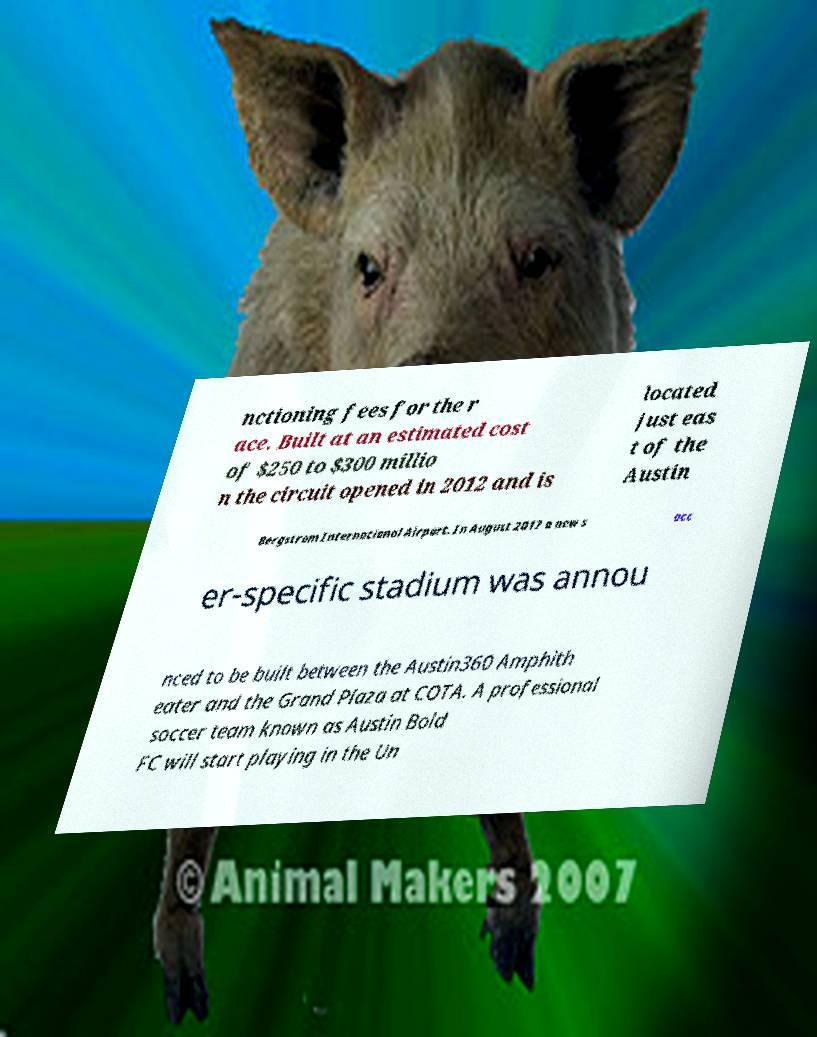Please identify and transcribe the text found in this image. nctioning fees for the r ace. Built at an estimated cost of $250 to $300 millio n the circuit opened in 2012 and is located just eas t of the Austin Bergstrom International Airport. In August 2017 a new s occ er-specific stadium was annou nced to be built between the Austin360 Amphith eater and the Grand Plaza at COTA. A professional soccer team known as Austin Bold FC will start playing in the Un 